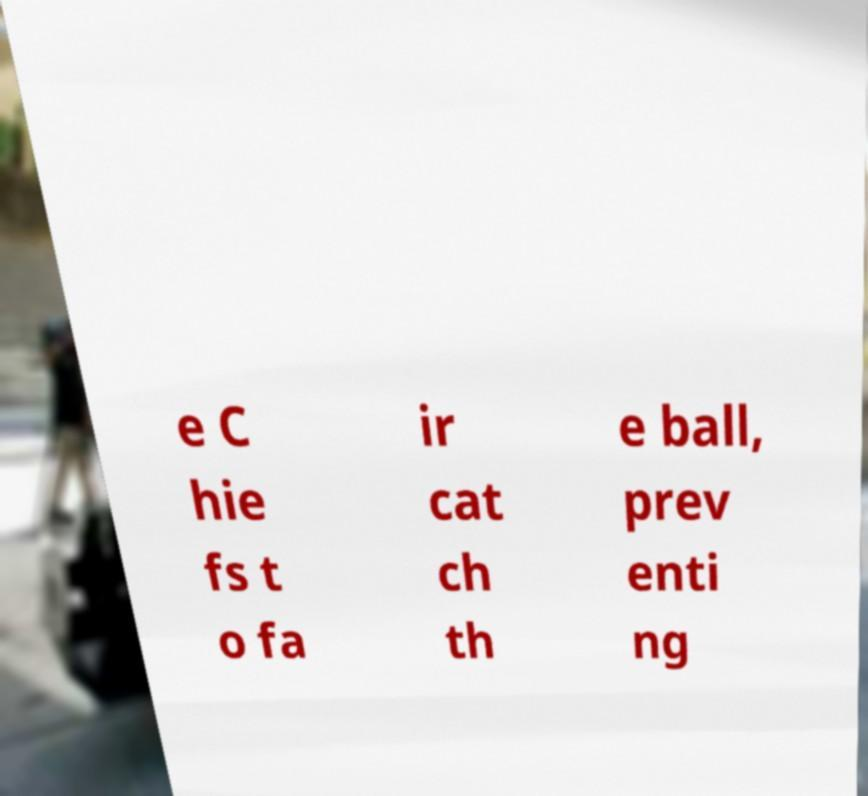Please identify and transcribe the text found in this image. e C hie fs t o fa ir cat ch th e ball, prev enti ng 